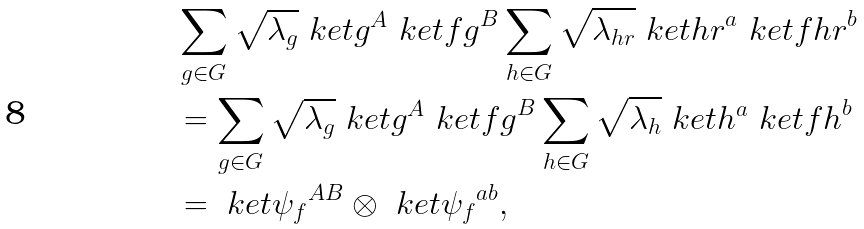<formula> <loc_0><loc_0><loc_500><loc_500>& \sum _ { g \in G } \sqrt { \lambda _ { g } } \ k e t { g } ^ { A } \ k e t { f g } ^ { B } \sum _ { h \in G } \sqrt { \lambda _ { h r } } \ k e t { h r } ^ { a } \ k e t { f h r } ^ { b } \\ & = \sum _ { g \in G } \sqrt { \lambda _ { g } } \ k e t { g } ^ { A } \ k e t { f g } ^ { B } \sum _ { h \in G } \sqrt { \lambda _ { h } } \ k e t { h } ^ { a } \ k e t { f h } ^ { b } \\ & = \ k e t { \psi _ { f } } ^ { A B } \otimes \ k e t { \psi _ { f } } ^ { a b } ,</formula> 